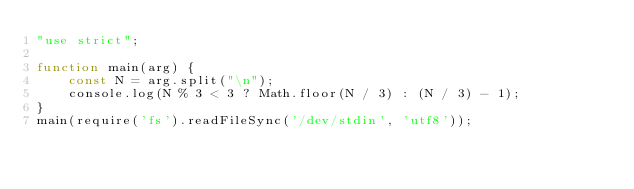<code> <loc_0><loc_0><loc_500><loc_500><_JavaScript_>"use strict";

function main(arg) {
    const N = arg.split("\n");
    console.log(N % 3 < 3 ? Math.floor(N / 3) : (N / 3) - 1);
}
main(require('fs').readFileSync('/dev/stdin', 'utf8'));</code> 